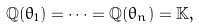Convert formula to latex. <formula><loc_0><loc_0><loc_500><loc_500>\mathbb { Q } ( \theta _ { 1 } ) = \cdots = \mathbb { Q } ( \theta _ { n } ) = \mathbb { K } ,</formula> 